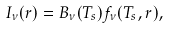Convert formula to latex. <formula><loc_0><loc_0><loc_500><loc_500>I _ { \nu } ( r ) = B _ { \nu } ( T _ { s } ) f _ { \nu } ( T _ { s } , r ) ,</formula> 